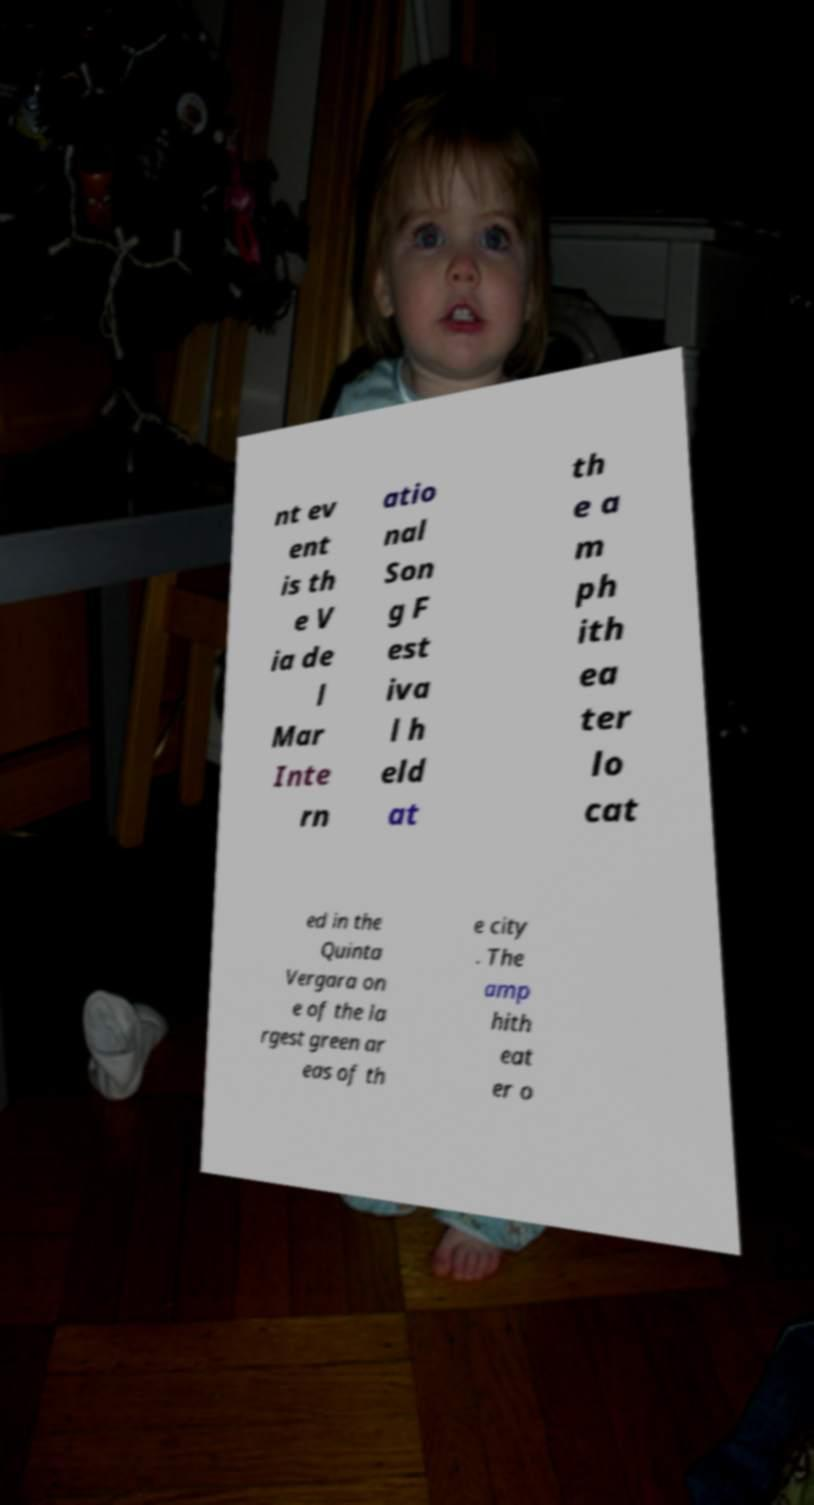Can you accurately transcribe the text from the provided image for me? nt ev ent is th e V ia de l Mar Inte rn atio nal Son g F est iva l h eld at th e a m ph ith ea ter lo cat ed in the Quinta Vergara on e of the la rgest green ar eas of th e city . The amp hith eat er o 